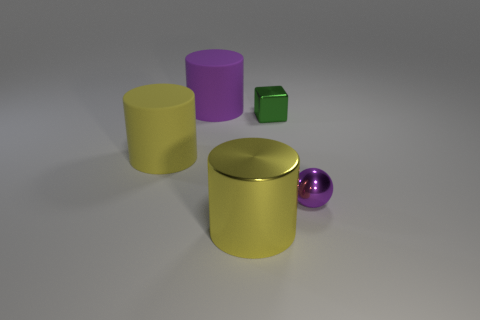Is the size of the yellow cylinder that is behind the tiny shiny sphere the same as the thing behind the small green object?
Ensure brevity in your answer.  Yes. Are there any other purple spheres that have the same material as the sphere?
Keep it short and to the point. No. What number of objects are big yellow cylinders that are in front of the large purple thing or big yellow objects?
Keep it short and to the point. 2. Do the green object behind the tiny purple metallic object and the purple ball have the same material?
Keep it short and to the point. Yes. Is the shape of the small green thing the same as the large yellow metallic object?
Offer a terse response. No. How many blocks are in front of the shiny thing to the left of the block?
Your response must be concise. 0. There is a purple object that is the same shape as the large yellow shiny thing; what material is it?
Make the answer very short. Rubber. Do the tiny ball that is in front of the green shiny thing and the tiny metal block have the same color?
Keep it short and to the point. No. Is the ball made of the same material as the big yellow thing on the left side of the yellow metallic thing?
Ensure brevity in your answer.  No. What shape is the object right of the metal block?
Your response must be concise. Sphere. 